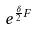<formula> <loc_0><loc_0><loc_500><loc_500>e ^ { \frac { \delta } { 2 } F }</formula> 